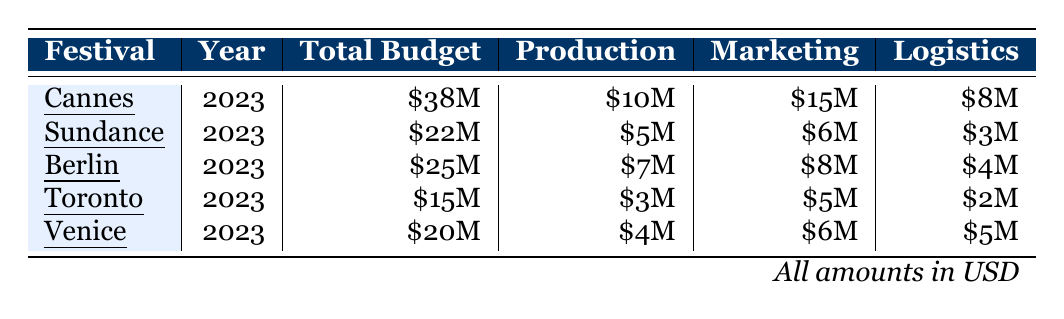What is the total budget for the Cannes Film Festival? The table shows that the total budget for the Cannes Film Festival in 2023 is listed as \$38 million.
Answer: \$38 million How much is allocated for marketing in the Sundance Film Festival? From the table, it can be seen that the allocation for marketing in the Sundance Film Festival is \$6 million.
Answer: \$6 million Which festival has the highest budget allocation for production support? By examining the production support allocations, Cannes has \$10 million, Berlin has \$7 million, Sundance has \$5 million, Toronto has \$3 million, and Venice has \$4 million. Thus, Cannes has the highest allocation at \$10 million.
Answer: Cannes What is the difference in total budget between the Toronto and Venice Film Festivals? The total budget for Toronto is \$15 million and for Venice is \$20 million. The difference is \$20 million - \$15 million = \$5 million.
Answer: \$5 million True or False: The total budget for the Berlin International Film Festival is greater than that of the Toronto International Film Festival. The Berlin budget is \$25 million, which is greater than Toronto's budget of \$15 million, so the statement is true.
Answer: True If you combine the logistics allocations of all five festivals, what is the total amount? The logistics allocations are \$8 million for Cannes, \$3 million for Sundance, \$4 million for Berlin, \$2 million for Toronto, and \$5 million for Venice. The total is \$8 million + \$3 million + \$4 million + \$2 million + \$5 million = \$22 million.
Answer: \$22 million What is the average allocation for translation services across all festivals? The translation services allocations are \$3 million (Cannes), \$5 million (Sundance), \$4 million (Berlin), \$2 million (Toronto), and \$3 million (Venice). The total is \$3 million + \$5 million + \$4 million + \$2 million + \$3 million = \$17 million. Since there are 5 festivals, the average allocation is \$17 million / 5 = \$3.4 million.
Answer: \$3.4 million Which festival has the lowest total budget? From the table, Toronto has the lowest total budget at \$15 million, compared to the other festivals.
Answer: Toronto Are the logistics allocations for the Berlin International Film Festival more than the combined total allocation for Toronto and Venice film festivals? The logistics allocation for Berlin is \$4 million. For Toronto, it’s \$2 million, and for Venice, it’s \$5 million. The combined total for Toronto and Venice is \$2 million + \$5 million = \$7 million, which is greater than Berlin's \$4 million. So, the statement is false.
Answer: False What percentage of the total budget for the Venice Film Festival is allocated for marketing? The total budget for Venice is \$20 million and the marketing allocation is \$6 million. The percentage is calculated as (\$6 million / \$20 million) * 100 = 30%.
Answer: 30% 